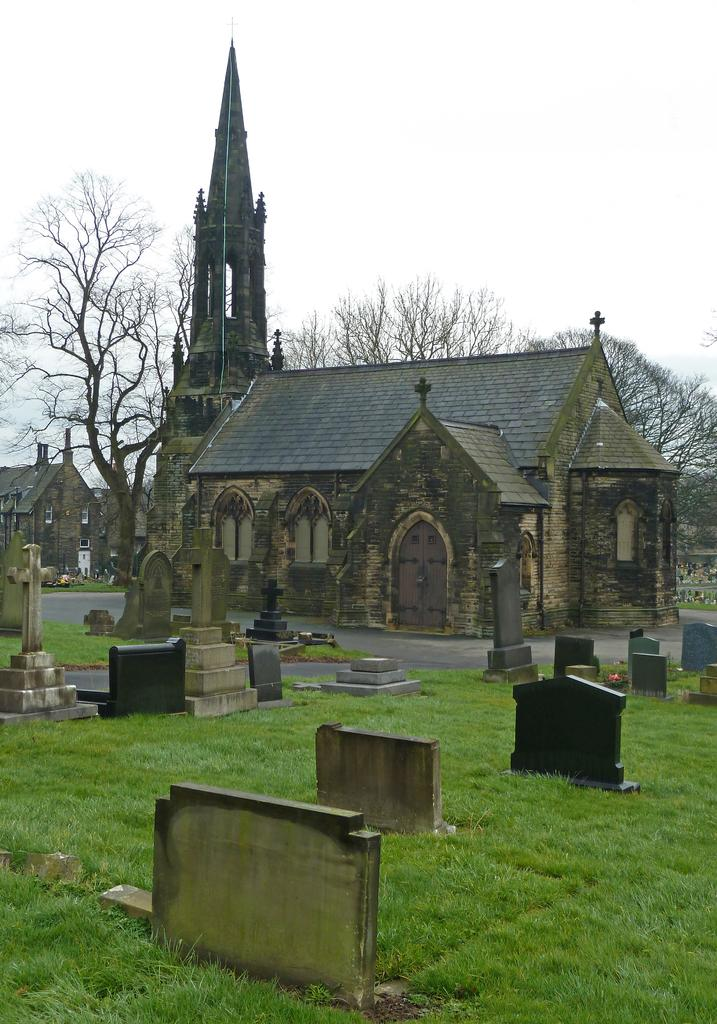What type of vegetation is present in the image? There is grass in the image. What other objects can be seen on the ground? There are stones in the image. What religious symbols are visible in the image? There are cross symbols in the image. What can be seen in the distance in the background of the image? There are buildings, trees, and a tower in the background of the image. What part of the natural environment is visible in the background of the image? The sky is visible in the background of the image. How much paste is required to cover the brain in the image? There is no brain or paste present in the image. What is the distance between the grass and the tower in the image? The facts provided do not give information about the distance between the grass and the tower, only that they are both present in the image. 